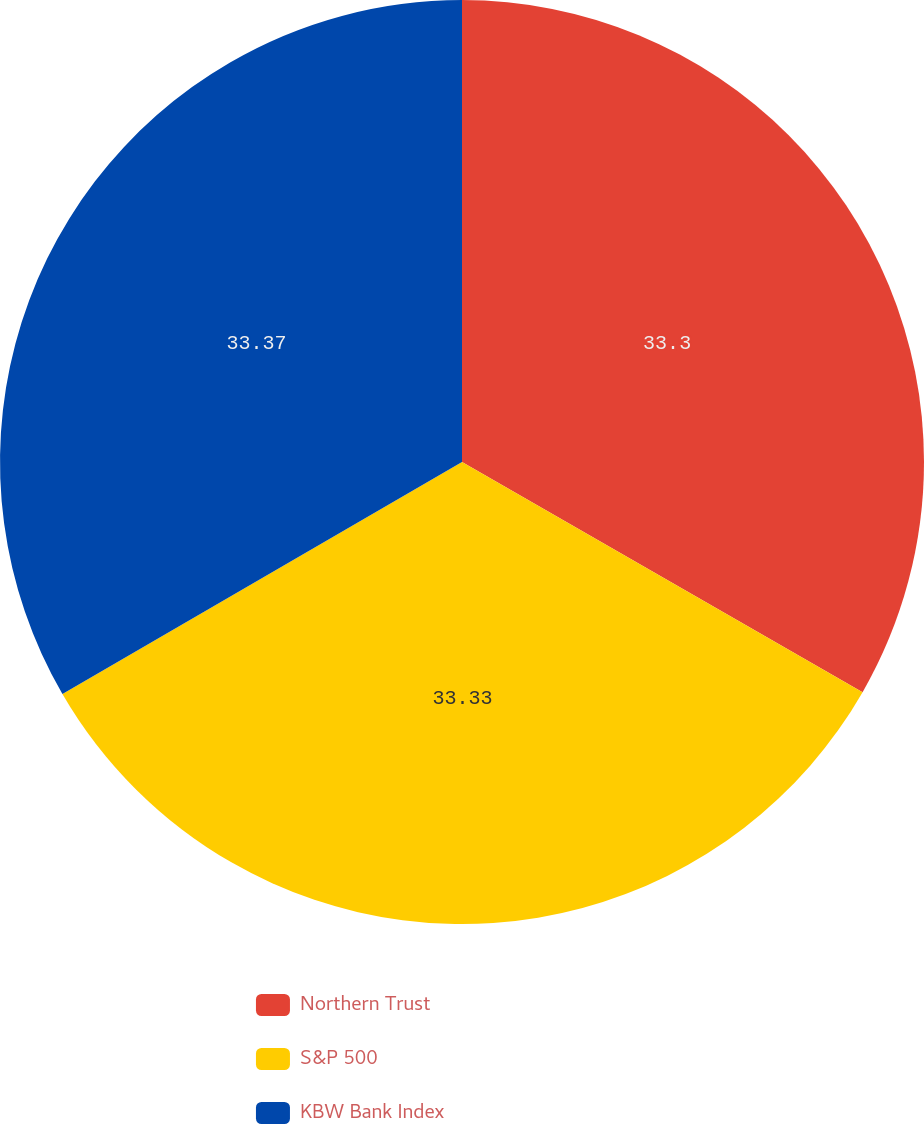Convert chart. <chart><loc_0><loc_0><loc_500><loc_500><pie_chart><fcel>Northern Trust<fcel>S&P 500<fcel>KBW Bank Index<nl><fcel>33.3%<fcel>33.33%<fcel>33.37%<nl></chart> 